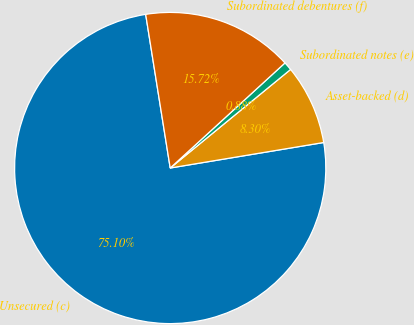Convert chart. <chart><loc_0><loc_0><loc_500><loc_500><pie_chart><fcel>Unsecured (c)<fcel>Asset-backed (d)<fcel>Subordinated notes (e)<fcel>Subordinated debentures (f)<nl><fcel>75.1%<fcel>8.3%<fcel>0.88%<fcel>15.72%<nl></chart> 